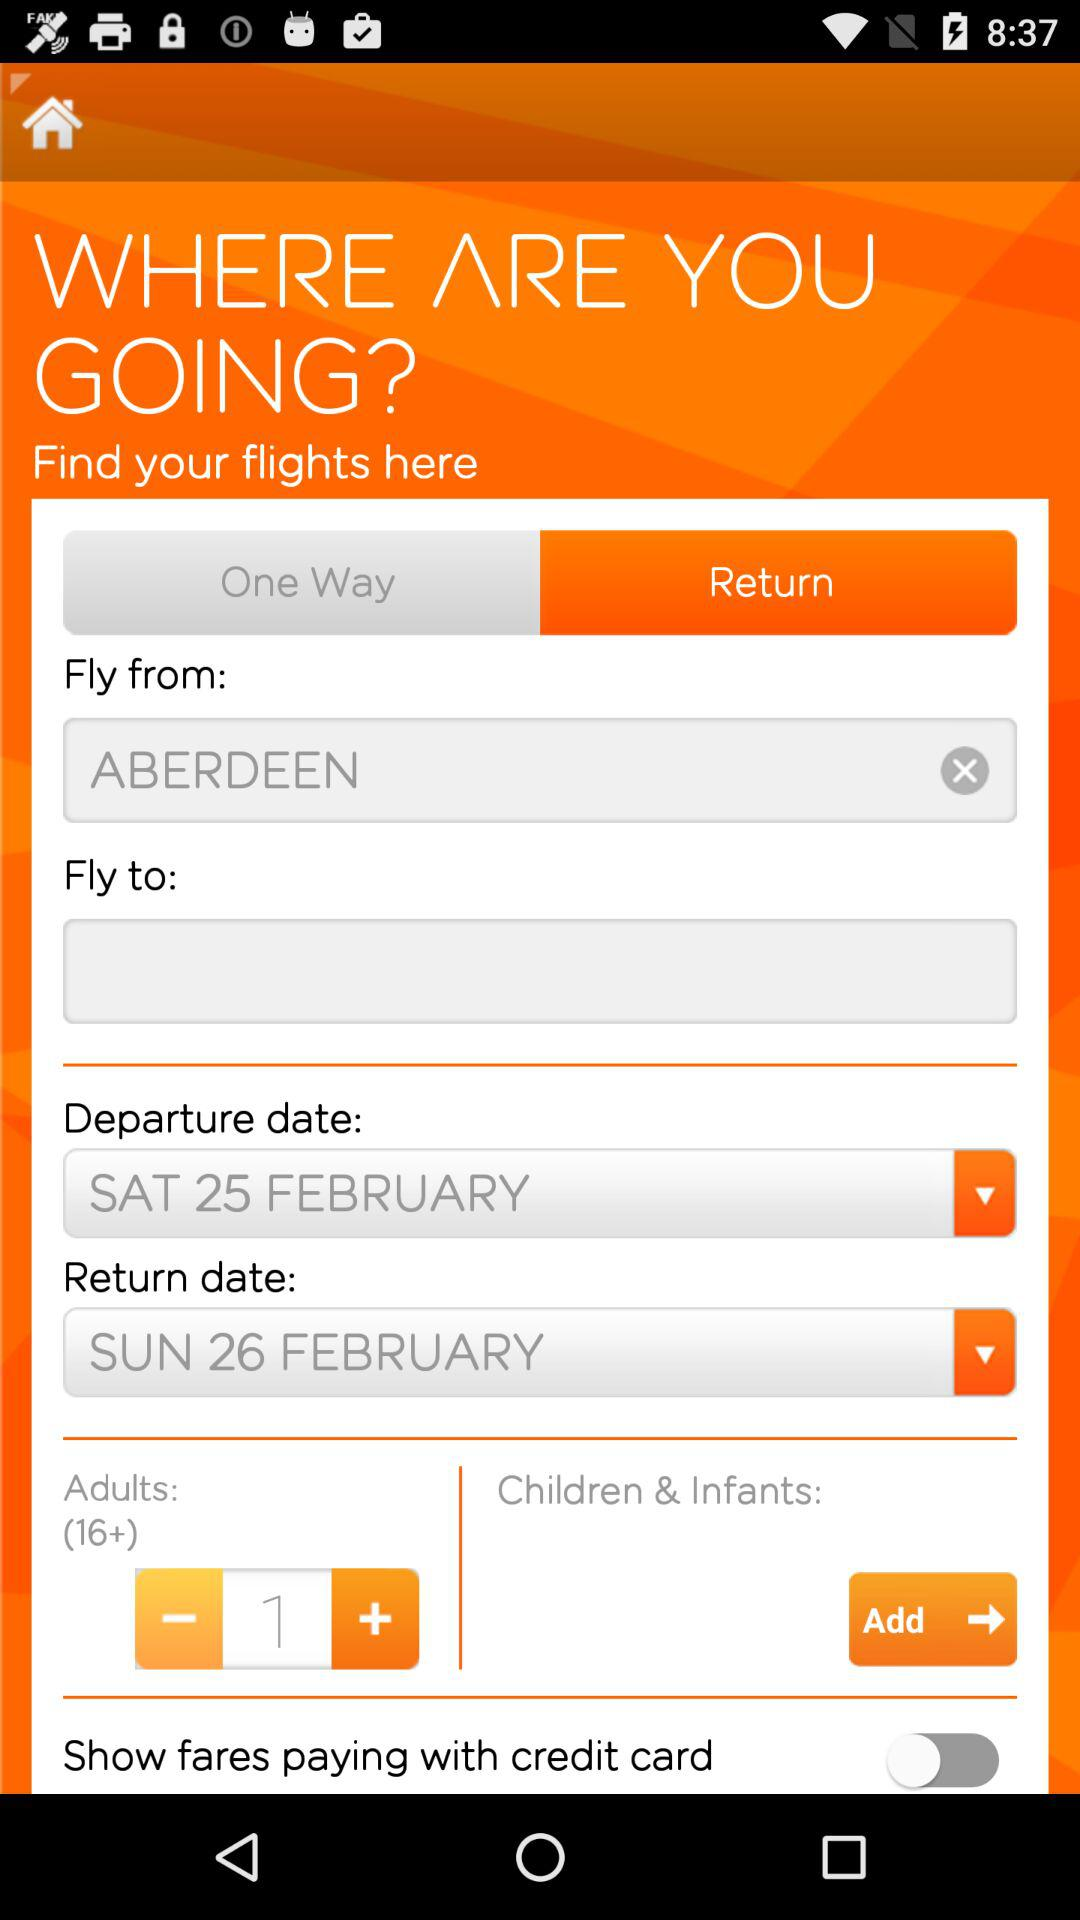What is the status of "Show fares paying with credit card"? The status is "off". 